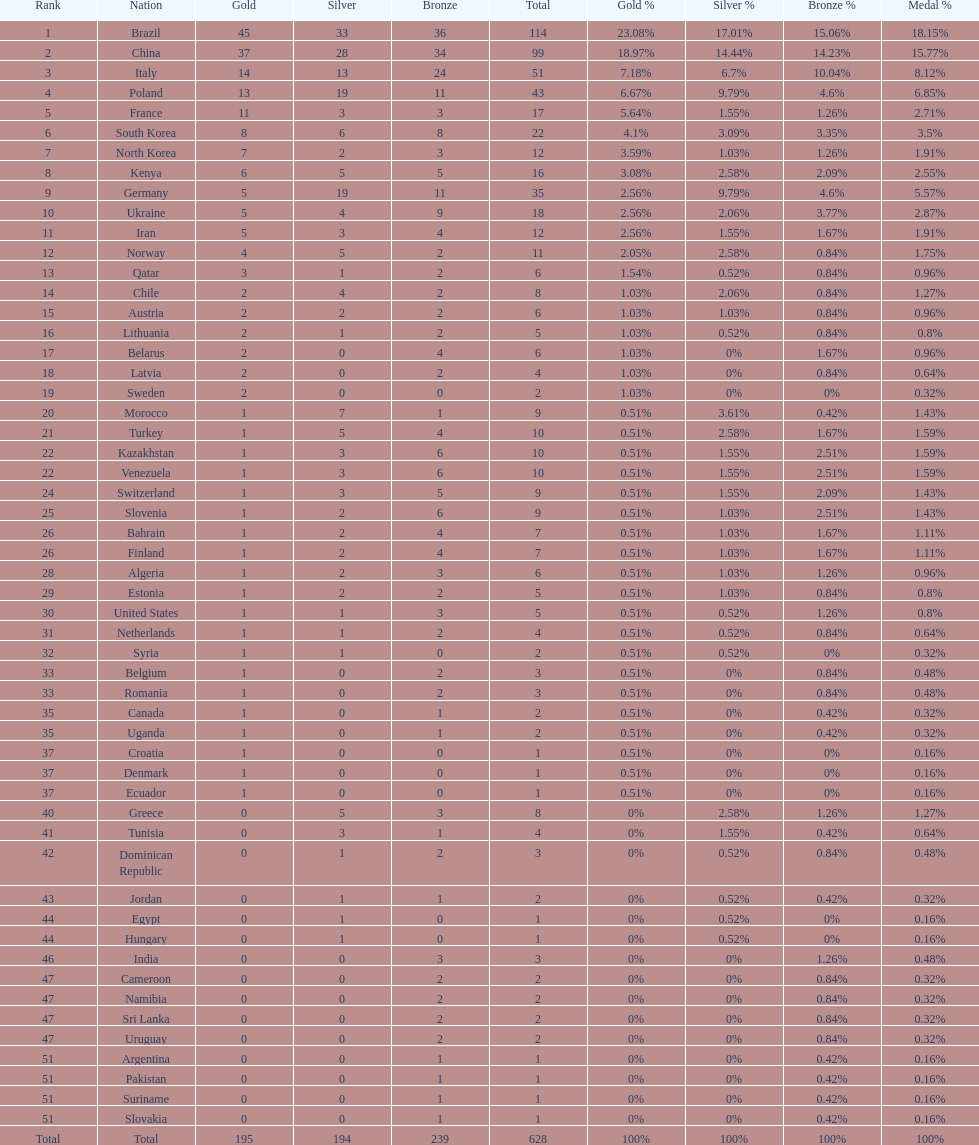What is the total number of medals between south korea, north korea, sweden, and brazil? 150. 